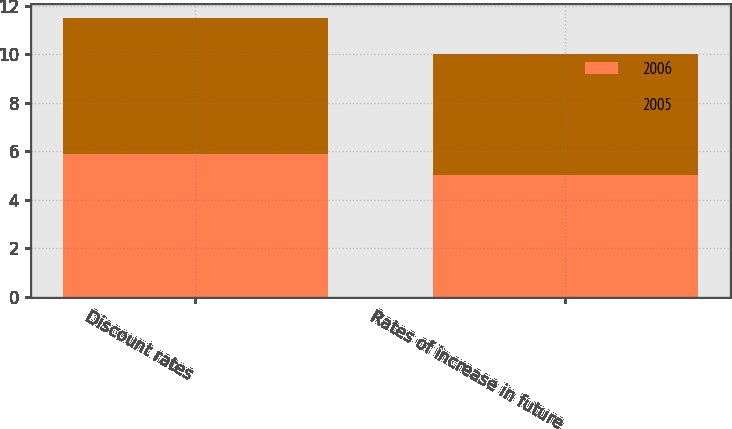Convert chart to OTSL. <chart><loc_0><loc_0><loc_500><loc_500><stacked_bar_chart><ecel><fcel>Discount rates<fcel>Rates of increase in future<nl><fcel>2006<fcel>5.88<fcel>5<nl><fcel>2005<fcel>5.62<fcel>5<nl></chart> 